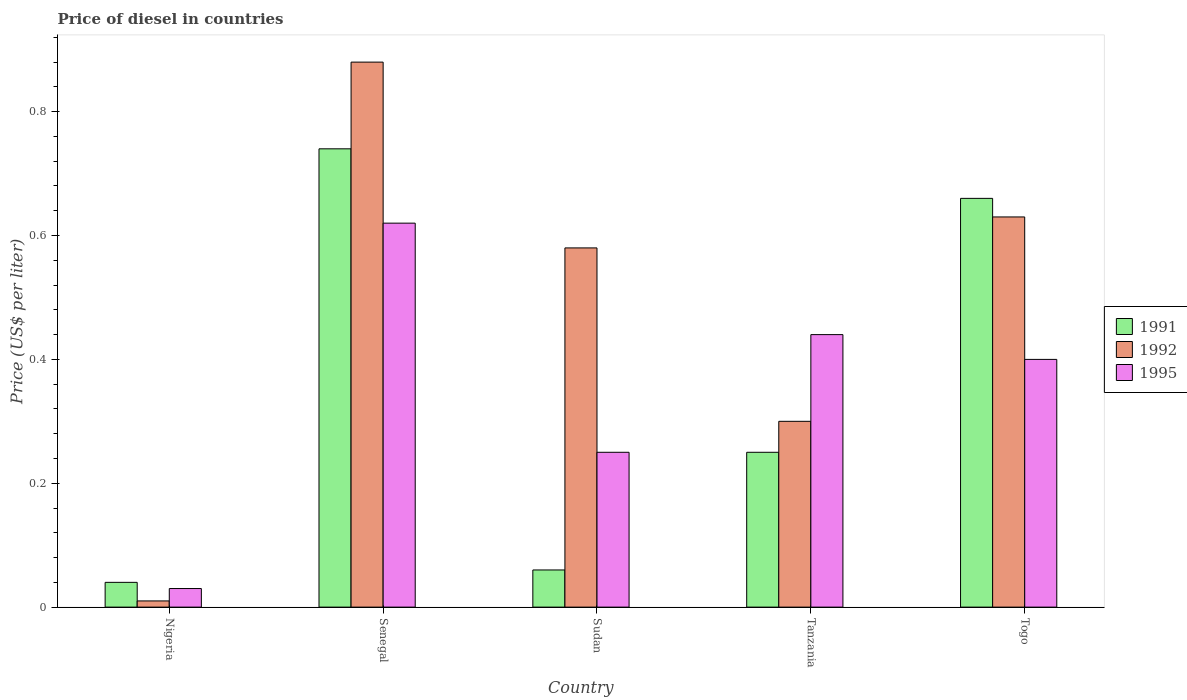How many different coloured bars are there?
Give a very brief answer. 3. How many groups of bars are there?
Make the answer very short. 5. Are the number of bars per tick equal to the number of legend labels?
Your answer should be compact. Yes. Are the number of bars on each tick of the X-axis equal?
Your answer should be compact. Yes. How many bars are there on the 5th tick from the left?
Your answer should be compact. 3. How many bars are there on the 3rd tick from the right?
Give a very brief answer. 3. What is the label of the 2nd group of bars from the left?
Keep it short and to the point. Senegal. What is the price of diesel in 1992 in Togo?
Your answer should be compact. 0.63. Across all countries, what is the maximum price of diesel in 1991?
Provide a succinct answer. 0.74. In which country was the price of diesel in 1991 maximum?
Your answer should be very brief. Senegal. In which country was the price of diesel in 1991 minimum?
Provide a succinct answer. Nigeria. What is the total price of diesel in 1992 in the graph?
Offer a terse response. 2.4. What is the difference between the price of diesel in 1992 in Sudan and the price of diesel in 1991 in Tanzania?
Give a very brief answer. 0.33. What is the average price of diesel in 1992 per country?
Provide a short and direct response. 0.48. What is the difference between the price of diesel of/in 1991 and price of diesel of/in 1995 in Sudan?
Ensure brevity in your answer.  -0.19. What is the ratio of the price of diesel in 1992 in Senegal to that in Togo?
Ensure brevity in your answer.  1.4. What is the difference between the highest and the second highest price of diesel in 1991?
Your answer should be compact. 0.08. What is the difference between the highest and the lowest price of diesel in 1992?
Give a very brief answer. 0.87. In how many countries, is the price of diesel in 1995 greater than the average price of diesel in 1995 taken over all countries?
Offer a very short reply. 3. What does the 1st bar from the left in Nigeria represents?
Ensure brevity in your answer.  1991. What does the 2nd bar from the right in Togo represents?
Offer a very short reply. 1992. Is it the case that in every country, the sum of the price of diesel in 1992 and price of diesel in 1995 is greater than the price of diesel in 1991?
Ensure brevity in your answer.  No. How many bars are there?
Give a very brief answer. 15. How many countries are there in the graph?
Your answer should be very brief. 5. What is the difference between two consecutive major ticks on the Y-axis?
Provide a short and direct response. 0.2. Are the values on the major ticks of Y-axis written in scientific E-notation?
Keep it short and to the point. No. Does the graph contain grids?
Offer a terse response. No. Where does the legend appear in the graph?
Offer a terse response. Center right. What is the title of the graph?
Provide a succinct answer. Price of diesel in countries. Does "1961" appear as one of the legend labels in the graph?
Provide a succinct answer. No. What is the label or title of the Y-axis?
Ensure brevity in your answer.  Price (US$ per liter). What is the Price (US$ per liter) in 1992 in Nigeria?
Your answer should be very brief. 0.01. What is the Price (US$ per liter) of 1995 in Nigeria?
Keep it short and to the point. 0.03. What is the Price (US$ per liter) of 1991 in Senegal?
Give a very brief answer. 0.74. What is the Price (US$ per liter) in 1995 in Senegal?
Your answer should be very brief. 0.62. What is the Price (US$ per liter) in 1992 in Sudan?
Your response must be concise. 0.58. What is the Price (US$ per liter) in 1992 in Tanzania?
Make the answer very short. 0.3. What is the Price (US$ per liter) in 1995 in Tanzania?
Your answer should be compact. 0.44. What is the Price (US$ per liter) in 1991 in Togo?
Offer a terse response. 0.66. What is the Price (US$ per liter) of 1992 in Togo?
Your answer should be compact. 0.63. Across all countries, what is the maximum Price (US$ per liter) in 1991?
Give a very brief answer. 0.74. Across all countries, what is the maximum Price (US$ per liter) in 1995?
Give a very brief answer. 0.62. Across all countries, what is the minimum Price (US$ per liter) in 1992?
Your answer should be compact. 0.01. Across all countries, what is the minimum Price (US$ per liter) of 1995?
Make the answer very short. 0.03. What is the total Price (US$ per liter) of 1991 in the graph?
Provide a short and direct response. 1.75. What is the total Price (US$ per liter) in 1992 in the graph?
Your response must be concise. 2.4. What is the total Price (US$ per liter) in 1995 in the graph?
Offer a very short reply. 1.74. What is the difference between the Price (US$ per liter) in 1991 in Nigeria and that in Senegal?
Give a very brief answer. -0.7. What is the difference between the Price (US$ per liter) in 1992 in Nigeria and that in Senegal?
Provide a succinct answer. -0.87. What is the difference between the Price (US$ per liter) of 1995 in Nigeria and that in Senegal?
Your answer should be compact. -0.59. What is the difference between the Price (US$ per liter) of 1991 in Nigeria and that in Sudan?
Make the answer very short. -0.02. What is the difference between the Price (US$ per liter) in 1992 in Nigeria and that in Sudan?
Your answer should be compact. -0.57. What is the difference between the Price (US$ per liter) of 1995 in Nigeria and that in Sudan?
Offer a terse response. -0.22. What is the difference between the Price (US$ per liter) of 1991 in Nigeria and that in Tanzania?
Keep it short and to the point. -0.21. What is the difference between the Price (US$ per liter) of 1992 in Nigeria and that in Tanzania?
Offer a very short reply. -0.29. What is the difference between the Price (US$ per liter) in 1995 in Nigeria and that in Tanzania?
Give a very brief answer. -0.41. What is the difference between the Price (US$ per liter) of 1991 in Nigeria and that in Togo?
Ensure brevity in your answer.  -0.62. What is the difference between the Price (US$ per liter) of 1992 in Nigeria and that in Togo?
Offer a terse response. -0.62. What is the difference between the Price (US$ per liter) in 1995 in Nigeria and that in Togo?
Give a very brief answer. -0.37. What is the difference between the Price (US$ per liter) in 1991 in Senegal and that in Sudan?
Your answer should be compact. 0.68. What is the difference between the Price (US$ per liter) of 1992 in Senegal and that in Sudan?
Offer a terse response. 0.3. What is the difference between the Price (US$ per liter) of 1995 in Senegal and that in Sudan?
Your answer should be compact. 0.37. What is the difference between the Price (US$ per liter) in 1991 in Senegal and that in Tanzania?
Ensure brevity in your answer.  0.49. What is the difference between the Price (US$ per liter) of 1992 in Senegal and that in Tanzania?
Offer a terse response. 0.58. What is the difference between the Price (US$ per liter) of 1995 in Senegal and that in Tanzania?
Keep it short and to the point. 0.18. What is the difference between the Price (US$ per liter) of 1991 in Senegal and that in Togo?
Ensure brevity in your answer.  0.08. What is the difference between the Price (US$ per liter) of 1995 in Senegal and that in Togo?
Offer a very short reply. 0.22. What is the difference between the Price (US$ per liter) of 1991 in Sudan and that in Tanzania?
Ensure brevity in your answer.  -0.19. What is the difference between the Price (US$ per liter) of 1992 in Sudan and that in Tanzania?
Your response must be concise. 0.28. What is the difference between the Price (US$ per liter) in 1995 in Sudan and that in Tanzania?
Keep it short and to the point. -0.19. What is the difference between the Price (US$ per liter) of 1991 in Sudan and that in Togo?
Keep it short and to the point. -0.6. What is the difference between the Price (US$ per liter) of 1991 in Tanzania and that in Togo?
Keep it short and to the point. -0.41. What is the difference between the Price (US$ per liter) of 1992 in Tanzania and that in Togo?
Your answer should be very brief. -0.33. What is the difference between the Price (US$ per liter) in 1995 in Tanzania and that in Togo?
Your answer should be compact. 0.04. What is the difference between the Price (US$ per liter) in 1991 in Nigeria and the Price (US$ per liter) in 1992 in Senegal?
Your answer should be very brief. -0.84. What is the difference between the Price (US$ per liter) in 1991 in Nigeria and the Price (US$ per liter) in 1995 in Senegal?
Your answer should be compact. -0.58. What is the difference between the Price (US$ per liter) of 1992 in Nigeria and the Price (US$ per liter) of 1995 in Senegal?
Give a very brief answer. -0.61. What is the difference between the Price (US$ per liter) of 1991 in Nigeria and the Price (US$ per liter) of 1992 in Sudan?
Provide a succinct answer. -0.54. What is the difference between the Price (US$ per liter) of 1991 in Nigeria and the Price (US$ per liter) of 1995 in Sudan?
Offer a very short reply. -0.21. What is the difference between the Price (US$ per liter) of 1992 in Nigeria and the Price (US$ per liter) of 1995 in Sudan?
Give a very brief answer. -0.24. What is the difference between the Price (US$ per liter) in 1991 in Nigeria and the Price (US$ per liter) in 1992 in Tanzania?
Provide a short and direct response. -0.26. What is the difference between the Price (US$ per liter) of 1992 in Nigeria and the Price (US$ per liter) of 1995 in Tanzania?
Offer a terse response. -0.43. What is the difference between the Price (US$ per liter) in 1991 in Nigeria and the Price (US$ per liter) in 1992 in Togo?
Make the answer very short. -0.59. What is the difference between the Price (US$ per liter) of 1991 in Nigeria and the Price (US$ per liter) of 1995 in Togo?
Your answer should be compact. -0.36. What is the difference between the Price (US$ per liter) of 1992 in Nigeria and the Price (US$ per liter) of 1995 in Togo?
Offer a very short reply. -0.39. What is the difference between the Price (US$ per liter) of 1991 in Senegal and the Price (US$ per liter) of 1992 in Sudan?
Your answer should be very brief. 0.16. What is the difference between the Price (US$ per liter) of 1991 in Senegal and the Price (US$ per liter) of 1995 in Sudan?
Your answer should be very brief. 0.49. What is the difference between the Price (US$ per liter) in 1992 in Senegal and the Price (US$ per liter) in 1995 in Sudan?
Make the answer very short. 0.63. What is the difference between the Price (US$ per liter) in 1991 in Senegal and the Price (US$ per liter) in 1992 in Tanzania?
Provide a succinct answer. 0.44. What is the difference between the Price (US$ per liter) of 1991 in Senegal and the Price (US$ per liter) of 1995 in Tanzania?
Ensure brevity in your answer.  0.3. What is the difference between the Price (US$ per liter) of 1992 in Senegal and the Price (US$ per liter) of 1995 in Tanzania?
Provide a short and direct response. 0.44. What is the difference between the Price (US$ per liter) in 1991 in Senegal and the Price (US$ per liter) in 1992 in Togo?
Offer a terse response. 0.11. What is the difference between the Price (US$ per liter) of 1991 in Senegal and the Price (US$ per liter) of 1995 in Togo?
Ensure brevity in your answer.  0.34. What is the difference between the Price (US$ per liter) of 1992 in Senegal and the Price (US$ per liter) of 1995 in Togo?
Provide a short and direct response. 0.48. What is the difference between the Price (US$ per liter) of 1991 in Sudan and the Price (US$ per liter) of 1992 in Tanzania?
Your response must be concise. -0.24. What is the difference between the Price (US$ per liter) of 1991 in Sudan and the Price (US$ per liter) of 1995 in Tanzania?
Your answer should be compact. -0.38. What is the difference between the Price (US$ per liter) in 1992 in Sudan and the Price (US$ per liter) in 1995 in Tanzania?
Keep it short and to the point. 0.14. What is the difference between the Price (US$ per liter) in 1991 in Sudan and the Price (US$ per liter) in 1992 in Togo?
Keep it short and to the point. -0.57. What is the difference between the Price (US$ per liter) in 1991 in Sudan and the Price (US$ per liter) in 1995 in Togo?
Make the answer very short. -0.34. What is the difference between the Price (US$ per liter) in 1992 in Sudan and the Price (US$ per liter) in 1995 in Togo?
Ensure brevity in your answer.  0.18. What is the difference between the Price (US$ per liter) of 1991 in Tanzania and the Price (US$ per liter) of 1992 in Togo?
Keep it short and to the point. -0.38. What is the difference between the Price (US$ per liter) of 1992 in Tanzania and the Price (US$ per liter) of 1995 in Togo?
Offer a terse response. -0.1. What is the average Price (US$ per liter) in 1992 per country?
Offer a terse response. 0.48. What is the average Price (US$ per liter) in 1995 per country?
Ensure brevity in your answer.  0.35. What is the difference between the Price (US$ per liter) of 1991 and Price (US$ per liter) of 1992 in Nigeria?
Offer a terse response. 0.03. What is the difference between the Price (US$ per liter) of 1991 and Price (US$ per liter) of 1995 in Nigeria?
Give a very brief answer. 0.01. What is the difference between the Price (US$ per liter) in 1992 and Price (US$ per liter) in 1995 in Nigeria?
Offer a very short reply. -0.02. What is the difference between the Price (US$ per liter) of 1991 and Price (US$ per liter) of 1992 in Senegal?
Your response must be concise. -0.14. What is the difference between the Price (US$ per liter) of 1991 and Price (US$ per liter) of 1995 in Senegal?
Ensure brevity in your answer.  0.12. What is the difference between the Price (US$ per liter) in 1992 and Price (US$ per liter) in 1995 in Senegal?
Your response must be concise. 0.26. What is the difference between the Price (US$ per liter) in 1991 and Price (US$ per liter) in 1992 in Sudan?
Your answer should be very brief. -0.52. What is the difference between the Price (US$ per liter) in 1991 and Price (US$ per liter) in 1995 in Sudan?
Offer a very short reply. -0.19. What is the difference between the Price (US$ per liter) of 1992 and Price (US$ per liter) of 1995 in Sudan?
Make the answer very short. 0.33. What is the difference between the Price (US$ per liter) in 1991 and Price (US$ per liter) in 1992 in Tanzania?
Provide a short and direct response. -0.05. What is the difference between the Price (US$ per liter) in 1991 and Price (US$ per liter) in 1995 in Tanzania?
Keep it short and to the point. -0.19. What is the difference between the Price (US$ per liter) of 1992 and Price (US$ per liter) of 1995 in Tanzania?
Ensure brevity in your answer.  -0.14. What is the difference between the Price (US$ per liter) in 1991 and Price (US$ per liter) in 1992 in Togo?
Give a very brief answer. 0.03. What is the difference between the Price (US$ per liter) of 1991 and Price (US$ per liter) of 1995 in Togo?
Keep it short and to the point. 0.26. What is the difference between the Price (US$ per liter) of 1992 and Price (US$ per liter) of 1995 in Togo?
Make the answer very short. 0.23. What is the ratio of the Price (US$ per liter) of 1991 in Nigeria to that in Senegal?
Make the answer very short. 0.05. What is the ratio of the Price (US$ per liter) of 1992 in Nigeria to that in Senegal?
Make the answer very short. 0.01. What is the ratio of the Price (US$ per liter) in 1995 in Nigeria to that in Senegal?
Your answer should be compact. 0.05. What is the ratio of the Price (US$ per liter) of 1991 in Nigeria to that in Sudan?
Your answer should be compact. 0.67. What is the ratio of the Price (US$ per liter) of 1992 in Nigeria to that in Sudan?
Keep it short and to the point. 0.02. What is the ratio of the Price (US$ per liter) of 1995 in Nigeria to that in Sudan?
Ensure brevity in your answer.  0.12. What is the ratio of the Price (US$ per liter) in 1991 in Nigeria to that in Tanzania?
Your answer should be very brief. 0.16. What is the ratio of the Price (US$ per liter) in 1995 in Nigeria to that in Tanzania?
Ensure brevity in your answer.  0.07. What is the ratio of the Price (US$ per liter) of 1991 in Nigeria to that in Togo?
Keep it short and to the point. 0.06. What is the ratio of the Price (US$ per liter) of 1992 in Nigeria to that in Togo?
Make the answer very short. 0.02. What is the ratio of the Price (US$ per liter) in 1995 in Nigeria to that in Togo?
Offer a terse response. 0.07. What is the ratio of the Price (US$ per liter) of 1991 in Senegal to that in Sudan?
Offer a terse response. 12.33. What is the ratio of the Price (US$ per liter) in 1992 in Senegal to that in Sudan?
Provide a succinct answer. 1.52. What is the ratio of the Price (US$ per liter) of 1995 in Senegal to that in Sudan?
Ensure brevity in your answer.  2.48. What is the ratio of the Price (US$ per liter) of 1991 in Senegal to that in Tanzania?
Offer a very short reply. 2.96. What is the ratio of the Price (US$ per liter) of 1992 in Senegal to that in Tanzania?
Provide a short and direct response. 2.93. What is the ratio of the Price (US$ per liter) of 1995 in Senegal to that in Tanzania?
Provide a succinct answer. 1.41. What is the ratio of the Price (US$ per liter) of 1991 in Senegal to that in Togo?
Ensure brevity in your answer.  1.12. What is the ratio of the Price (US$ per liter) in 1992 in Senegal to that in Togo?
Your answer should be very brief. 1.4. What is the ratio of the Price (US$ per liter) in 1995 in Senegal to that in Togo?
Provide a succinct answer. 1.55. What is the ratio of the Price (US$ per liter) in 1991 in Sudan to that in Tanzania?
Your answer should be very brief. 0.24. What is the ratio of the Price (US$ per liter) of 1992 in Sudan to that in Tanzania?
Your answer should be compact. 1.93. What is the ratio of the Price (US$ per liter) of 1995 in Sudan to that in Tanzania?
Provide a succinct answer. 0.57. What is the ratio of the Price (US$ per liter) in 1991 in Sudan to that in Togo?
Ensure brevity in your answer.  0.09. What is the ratio of the Price (US$ per liter) in 1992 in Sudan to that in Togo?
Offer a terse response. 0.92. What is the ratio of the Price (US$ per liter) of 1991 in Tanzania to that in Togo?
Ensure brevity in your answer.  0.38. What is the ratio of the Price (US$ per liter) of 1992 in Tanzania to that in Togo?
Provide a succinct answer. 0.48. What is the ratio of the Price (US$ per liter) of 1995 in Tanzania to that in Togo?
Offer a terse response. 1.1. What is the difference between the highest and the second highest Price (US$ per liter) of 1991?
Offer a very short reply. 0.08. What is the difference between the highest and the second highest Price (US$ per liter) of 1992?
Your answer should be very brief. 0.25. What is the difference between the highest and the second highest Price (US$ per liter) of 1995?
Your answer should be compact. 0.18. What is the difference between the highest and the lowest Price (US$ per liter) in 1991?
Offer a terse response. 0.7. What is the difference between the highest and the lowest Price (US$ per liter) in 1992?
Offer a very short reply. 0.87. What is the difference between the highest and the lowest Price (US$ per liter) in 1995?
Provide a short and direct response. 0.59. 